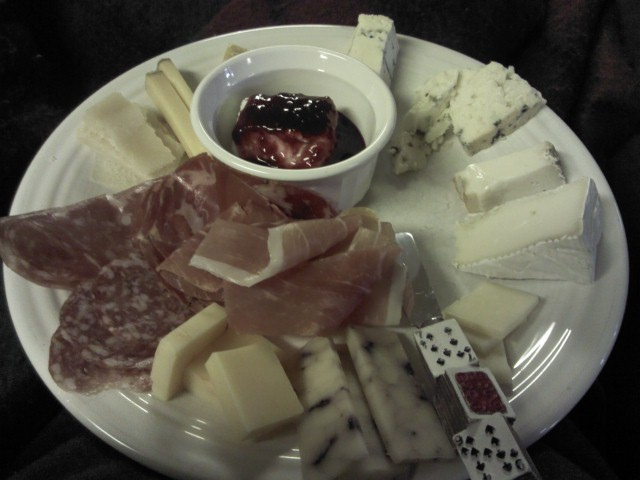Identify the text displayed in this image. 9 